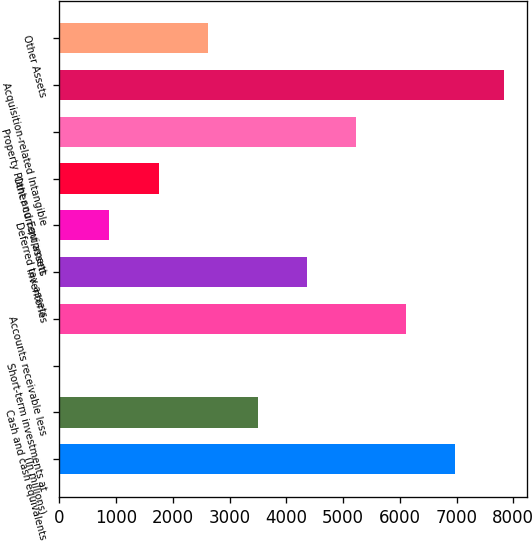<chart> <loc_0><loc_0><loc_500><loc_500><bar_chart><fcel>(In millions)<fcel>Cash and cash equivalents<fcel>Short-term investments at<fcel>Accounts receivable less<fcel>Inventories<fcel>Deferred tax assets<fcel>Other current assets<fcel>Property Plant and Equipment<fcel>Acquisition-related Intangible<fcel>Other Assets<nl><fcel>6973.38<fcel>3493.74<fcel>14.1<fcel>6103.47<fcel>4363.65<fcel>884.01<fcel>1753.92<fcel>5233.56<fcel>7843.29<fcel>2623.83<nl></chart> 